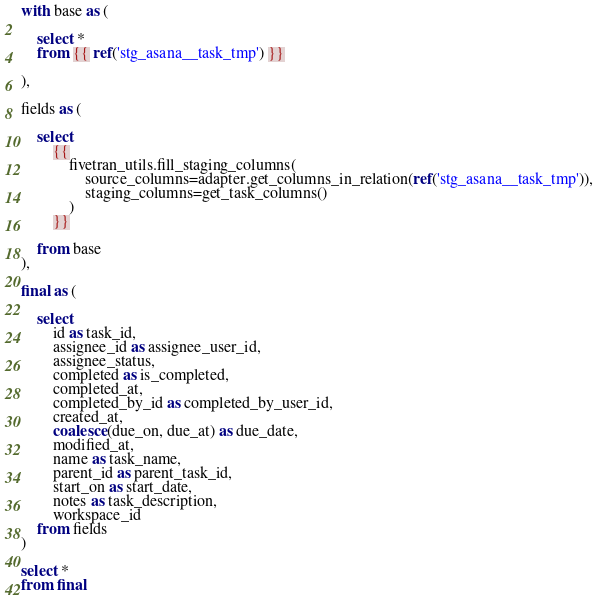Convert code to text. <code><loc_0><loc_0><loc_500><loc_500><_SQL_>
with base as (

    select * 
    from {{ ref('stg_asana__task_tmp') }}

),

fields as (

    select
        {{
            fivetran_utils.fill_staging_columns(
                source_columns=adapter.get_columns_in_relation(ref('stg_asana__task_tmp')),
                staging_columns=get_task_columns()
            )
        }}
        
    from base
),

final as (
    
    select 
        id as task_id,
        assignee_id as assignee_user_id,
        assignee_status,
        completed as is_completed,
        completed_at,
        completed_by_id as completed_by_user_id,
        created_at,
        coalesce(due_on, due_at) as due_date,
        modified_at,
        name as task_name,
        parent_id as parent_task_id,
        start_on as start_date,
        notes as task_description,
        workspace_id
    from fields
)

select * 
from final
</code> 